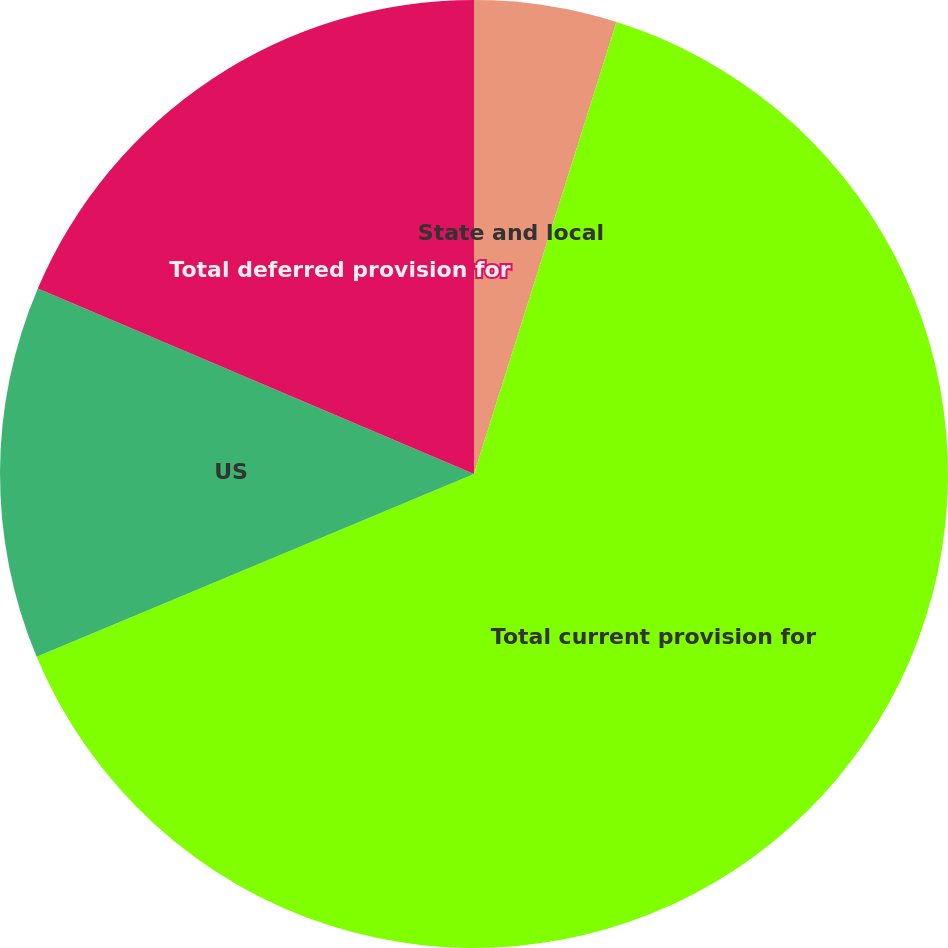Convert chart. <chart><loc_0><loc_0><loc_500><loc_500><pie_chart><fcel>State and local<fcel>Total current provision for<fcel>US<fcel>Total deferred provision for<nl><fcel>4.86%<fcel>63.84%<fcel>12.7%<fcel>18.6%<nl></chart> 